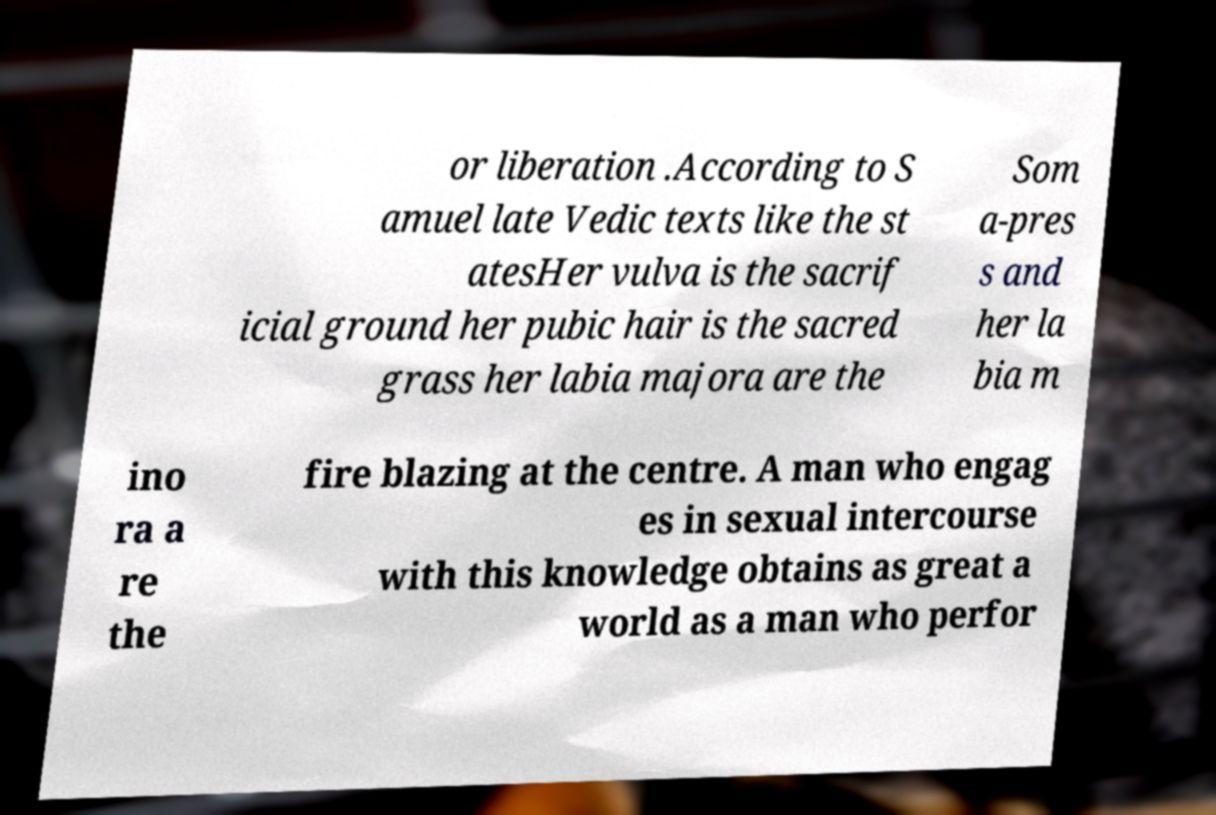There's text embedded in this image that I need extracted. Can you transcribe it verbatim? or liberation .According to S amuel late Vedic texts like the st atesHer vulva is the sacrif icial ground her pubic hair is the sacred grass her labia majora are the Som a-pres s and her la bia m ino ra a re the fire blazing at the centre. A man who engag es in sexual intercourse with this knowledge obtains as great a world as a man who perfor 